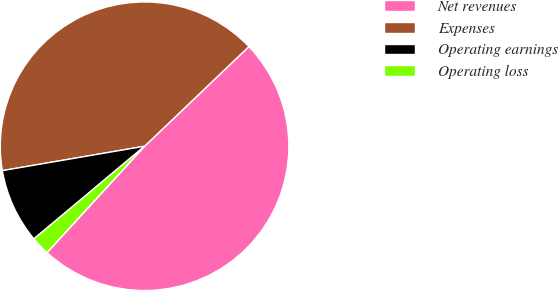<chart> <loc_0><loc_0><loc_500><loc_500><pie_chart><fcel>Net revenues<fcel>Expenses<fcel>Operating earnings<fcel>Operating loss<nl><fcel>48.96%<fcel>40.57%<fcel>8.39%<fcel>2.09%<nl></chart> 